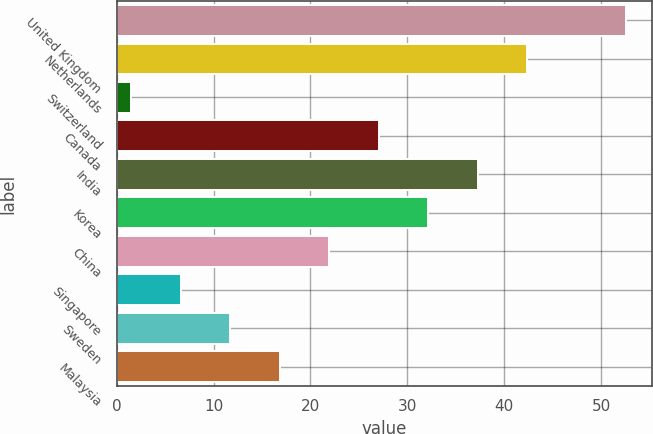<chart> <loc_0><loc_0><loc_500><loc_500><bar_chart><fcel>United Kingdom<fcel>Netherlands<fcel>Switzerland<fcel>Canada<fcel>India<fcel>Korea<fcel>China<fcel>Singapore<fcel>Sweden<fcel>Malaysia<nl><fcel>52.6<fcel>42.38<fcel>1.5<fcel>27.05<fcel>37.27<fcel>32.16<fcel>21.94<fcel>6.61<fcel>11.72<fcel>16.83<nl></chart> 